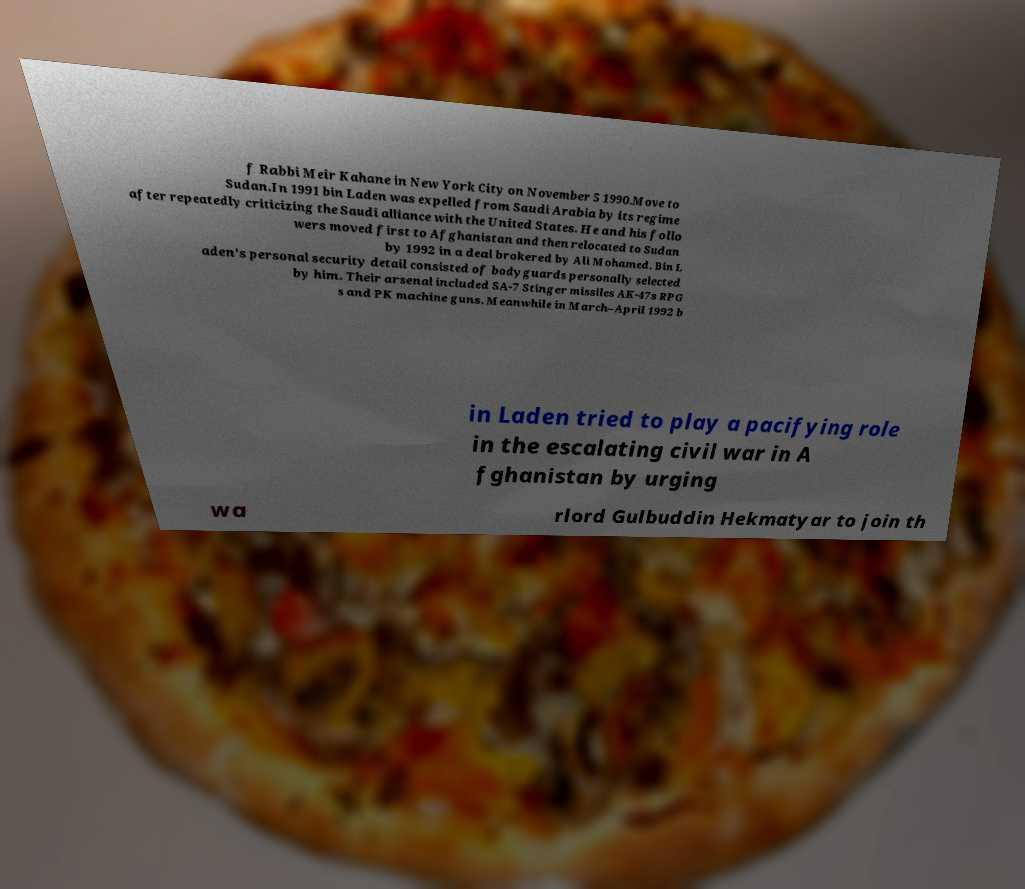For documentation purposes, I need the text within this image transcribed. Could you provide that? f Rabbi Meir Kahane in New York City on November 5 1990.Move to Sudan.In 1991 bin Laden was expelled from Saudi Arabia by its regime after repeatedly criticizing the Saudi alliance with the United States. He and his follo wers moved first to Afghanistan and then relocated to Sudan by 1992 in a deal brokered by Ali Mohamed. Bin L aden's personal security detail consisted of bodyguards personally selected by him. Their arsenal included SA-7 Stinger missiles AK-47s RPG s and PK machine guns. Meanwhile in March–April 1992 b in Laden tried to play a pacifying role in the escalating civil war in A fghanistan by urging wa rlord Gulbuddin Hekmatyar to join th 